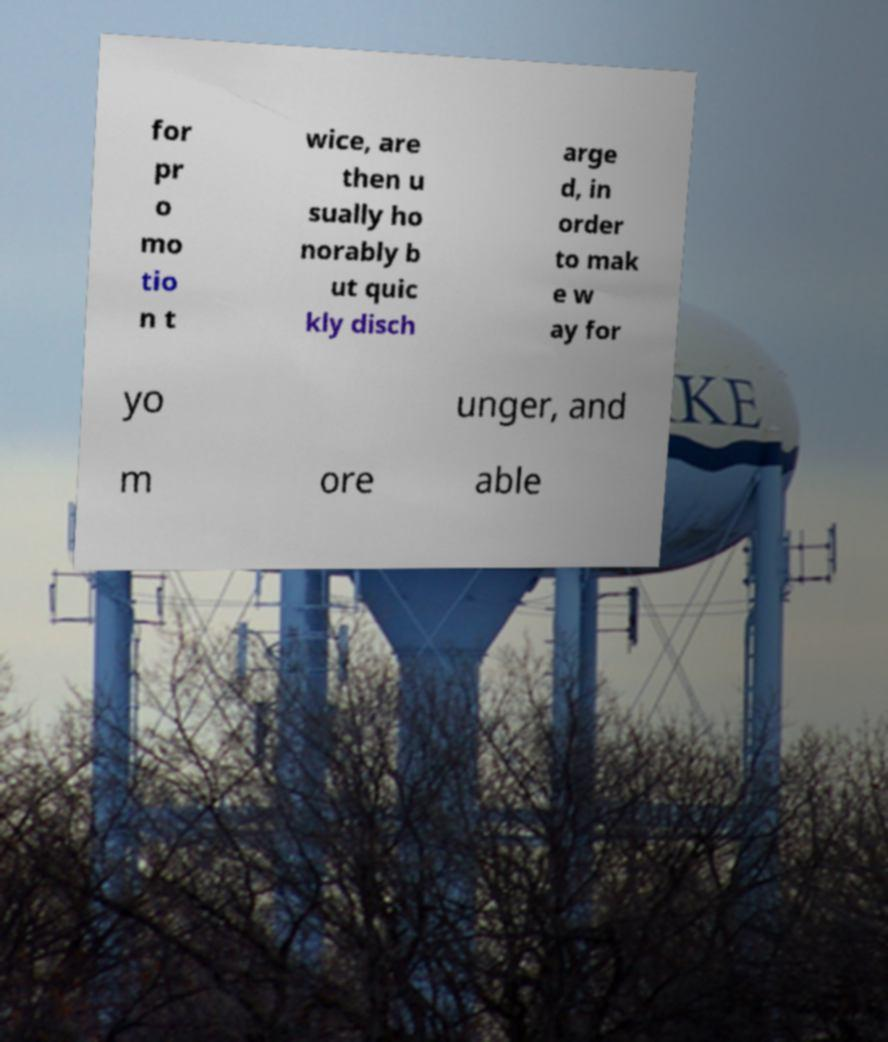There's text embedded in this image that I need extracted. Can you transcribe it verbatim? for pr o mo tio n t wice, are then u sually ho norably b ut quic kly disch arge d, in order to mak e w ay for yo unger, and m ore able 